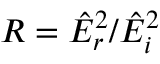<formula> <loc_0><loc_0><loc_500><loc_500>R = \hat { E } _ { r } ^ { 2 } / \hat { E } _ { i } ^ { 2 }</formula> 